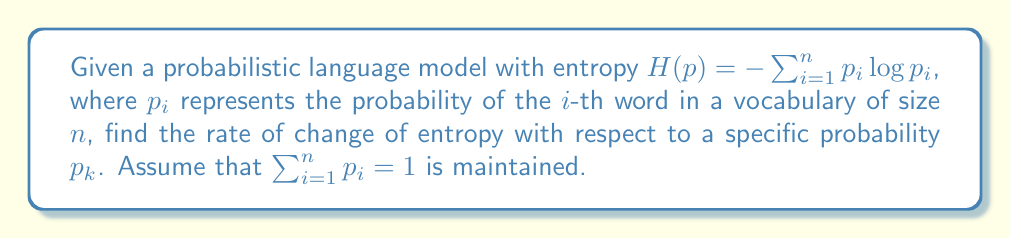Can you solve this math problem? To find the rate of change of entropy with respect to $p_k$, we need to calculate the partial derivative of $H(p)$ with respect to $p_k$:

1) First, let's express the entropy function:
   $$H(p) = -\sum_{i=1}^n p_i \log p_i$$

2) To maintain the constraint $\sum_{i=1}^n p_i = 1$, we need to consider that changing $p_k$ affects other probabilities. Let's assume that the change is distributed equally among all other probabilities. This means:
   $$\frac{\partial p_i}{\partial p_k} = -\frac{1}{n-1} \text{ for } i \neq k$$

3) Now, let's calculate the partial derivative:
   $$\frac{\partial H}{\partial p_k} = -\frac{\partial}{\partial p_k}\left(\sum_{i=1}^n p_i \log p_i\right)$$

4) Using the product rule and chain rule:
   $$\frac{\partial H}{\partial p_k} = -\left(\log p_k + 1 + \sum_{i\neq k} \frac{\partial p_i}{\partial p_k}(\log p_i + 1)\right)$$

5) Substituting the value of $\frac{\partial p_i}{\partial p_k}$ from step 2:
   $$\frac{\partial H}{\partial p_k} = -\left(\log p_k + 1 - \frac{1}{n-1}\sum_{i\neq k}(\log p_i + 1)\right)$$

6) Simplifying:
   $$\frac{\partial H}{\partial p_k} = -\log p_k - 1 + \frac{1}{n-1}\sum_{i\neq k}(\log p_i + 1)$$

This expression represents the rate of change of entropy with respect to $p_k$ in the probabilistic language model.
Answer: $-\log p_k - 1 + \frac{1}{n-1}\sum_{i\neq k}(\log p_i + 1)$ 